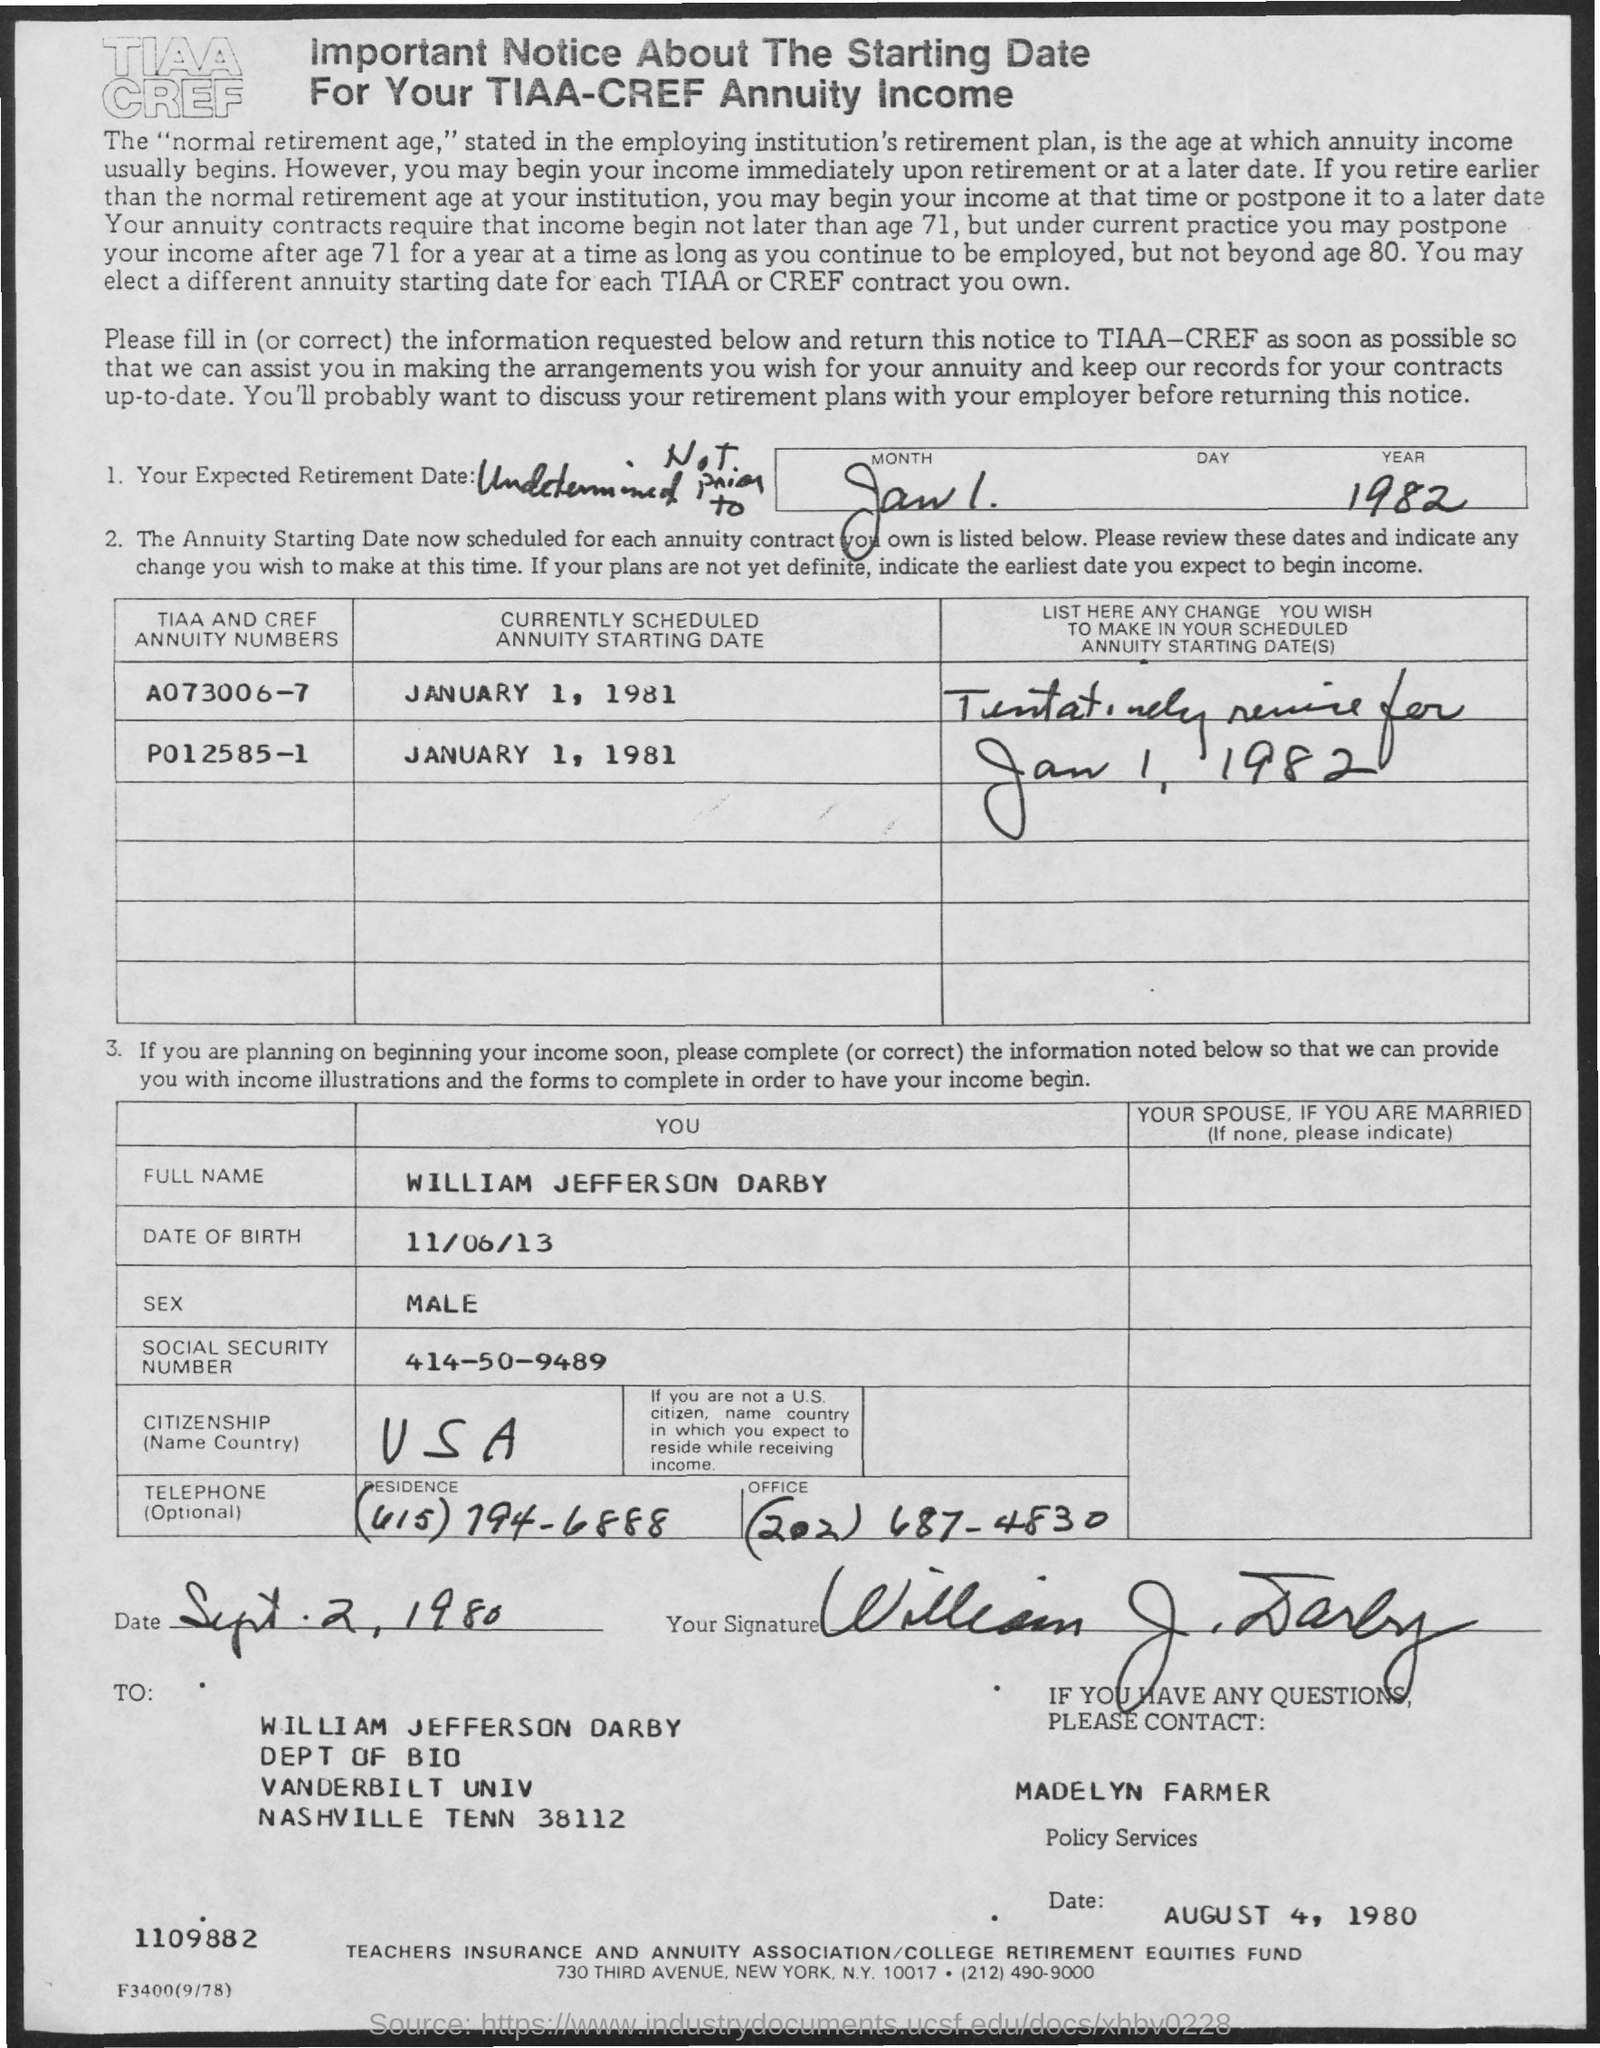What is the currently scheduled annuity starting date of A073006-7?
Offer a very short reply. January 1, 1981. What is the full name given?
Offer a very short reply. WILLIAM JEFFERSON DARBY. What is the date of birth given?
Offer a terse response. 11/06/13. What is the SOCIAL SECURITY NUMBER?
Ensure brevity in your answer.  414-50-9489. What is the office telephone number given?
Keep it short and to the point. (202) 687-4830. When did Darby sign this?
Provide a succinct answer. Sept. 2, 1980. Whom to contact for questions?
Offer a very short reply. Madelyn farmer. What is the important notice about?
Your answer should be compact. The Starting Date For Your TIAA-CREF Annuity Income. 